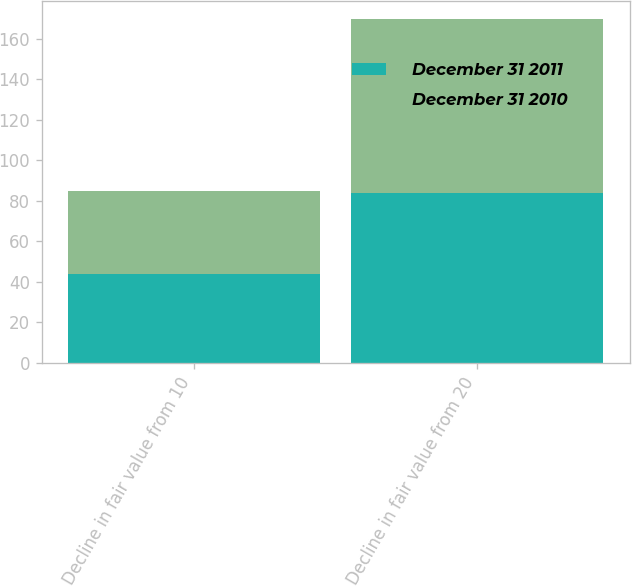Convert chart to OTSL. <chart><loc_0><loc_0><loc_500><loc_500><stacked_bar_chart><ecel><fcel>Decline in fair value from 10<fcel>Decline in fair value from 20<nl><fcel>December 31 2011<fcel>44<fcel>84<nl><fcel>December 31 2010<fcel>41<fcel>86<nl></chart> 